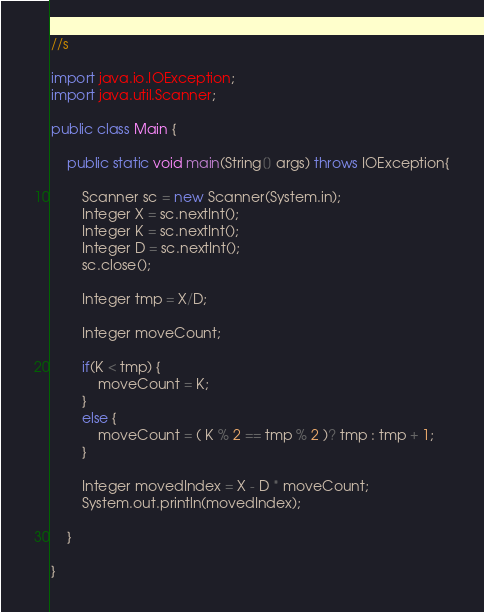Convert code to text. <code><loc_0><loc_0><loc_500><loc_500><_Java_>//s

import java.io.IOException;
import java.util.Scanner;

public class Main {

	public static void main(String[] args) throws IOException{
		
		Scanner sc = new Scanner(System.in);
		Integer X = sc.nextInt();
		Integer K = sc.nextInt();
		Integer D = sc.nextInt();
		sc.close();

		Integer tmp = X/D;
		
		Integer moveCount;
		
		if(K < tmp) {
			moveCount = K;
		}
		else {
			moveCount = ( K % 2 == tmp % 2 )? tmp : tmp + 1;
		}

		Integer movedIndex = X - D * moveCount;
		System.out.println(movedIndex);

	}

}
</code> 